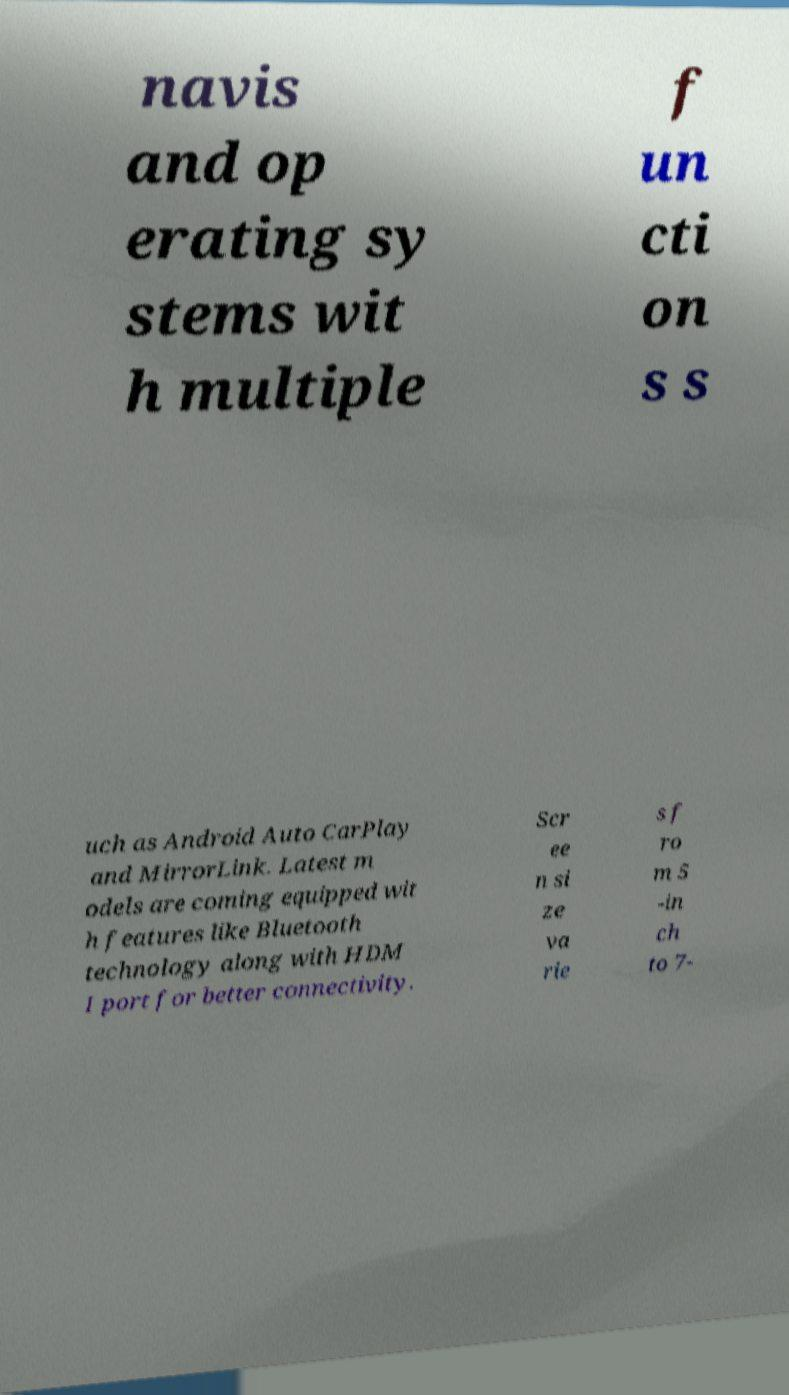Can you read and provide the text displayed in the image?This photo seems to have some interesting text. Can you extract and type it out for me? navis and op erating sy stems wit h multiple f un cti on s s uch as Android Auto CarPlay and MirrorLink. Latest m odels are coming equipped wit h features like Bluetooth technology along with HDM I port for better connectivity. Scr ee n si ze va rie s f ro m 5 -in ch to 7- 